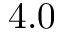Convert formula to latex. <formula><loc_0><loc_0><loc_500><loc_500>4 . 0</formula> 